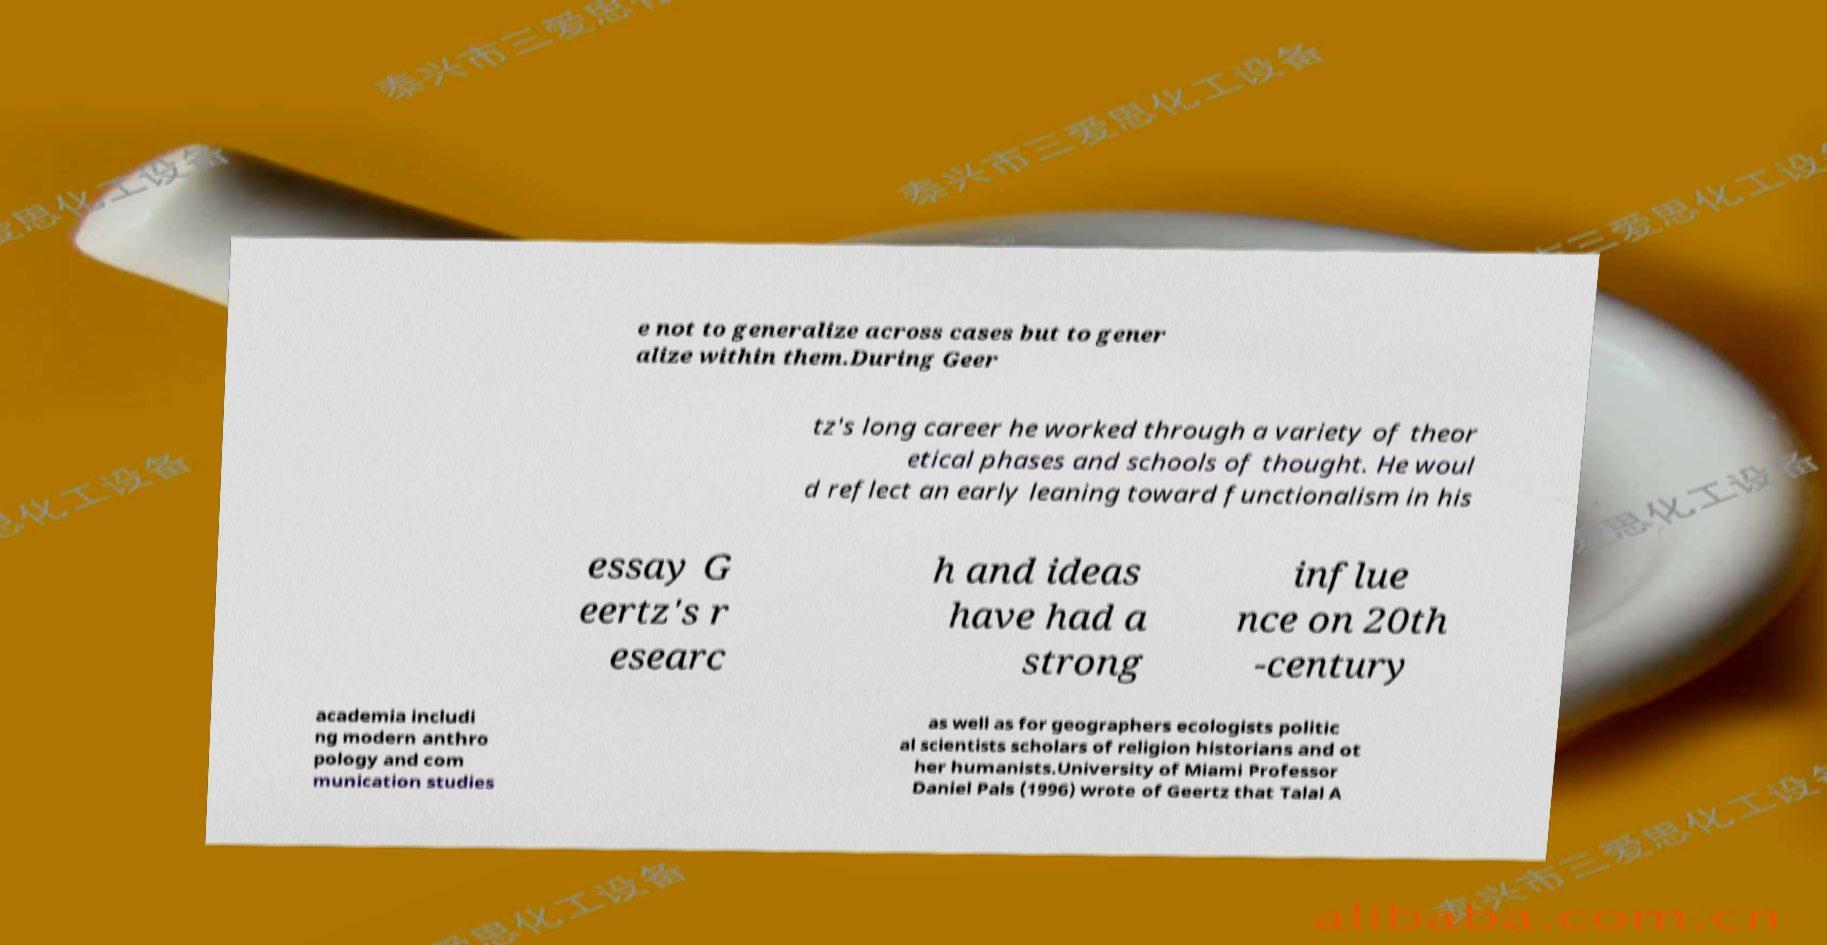What messages or text are displayed in this image? I need them in a readable, typed format. e not to generalize across cases but to gener alize within them.During Geer tz's long career he worked through a variety of theor etical phases and schools of thought. He woul d reflect an early leaning toward functionalism in his essay G eertz's r esearc h and ideas have had a strong influe nce on 20th -century academia includi ng modern anthro pology and com munication studies as well as for geographers ecologists politic al scientists scholars of religion historians and ot her humanists.University of Miami Professor Daniel Pals (1996) wrote of Geertz that Talal A 